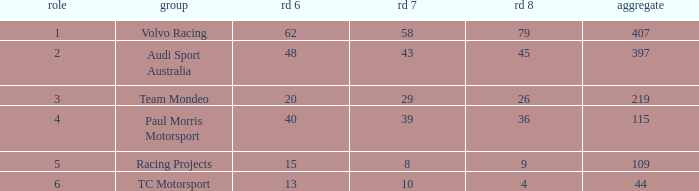What is the average value for Rd 8 in a position less than 2 for Audi Sport Australia? None. 